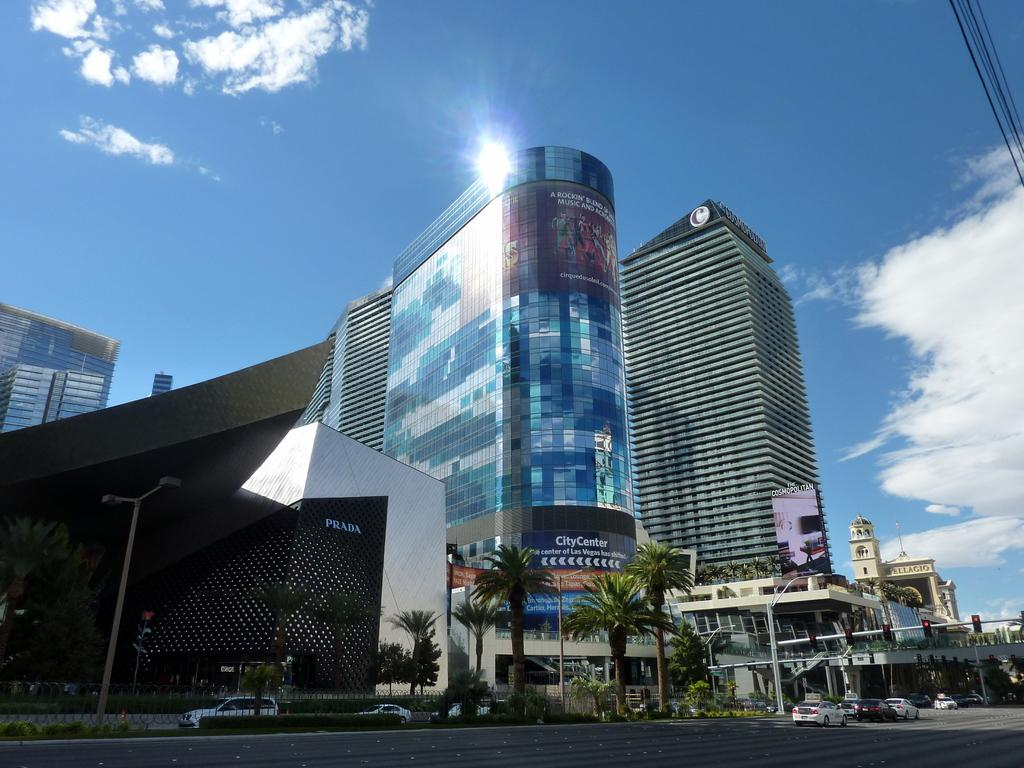<image>
Share a concise interpretation of the image provided. A few buildings with sunlight glinting off the top of the City Center. 